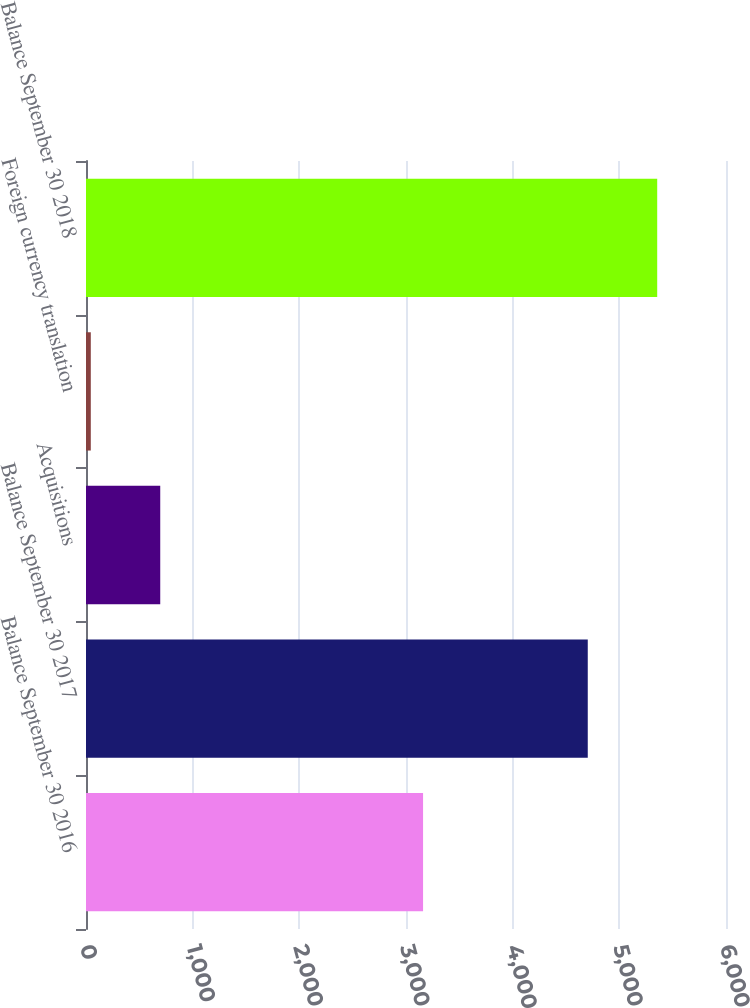Convert chart. <chart><loc_0><loc_0><loc_500><loc_500><bar_chart><fcel>Balance September 30 2016<fcel>Balance September 30 2017<fcel>Acquisitions<fcel>Foreign currency translation<fcel>Balance September 30 2018<nl><fcel>3160<fcel>4704<fcel>696<fcel>45<fcel>5355<nl></chart> 